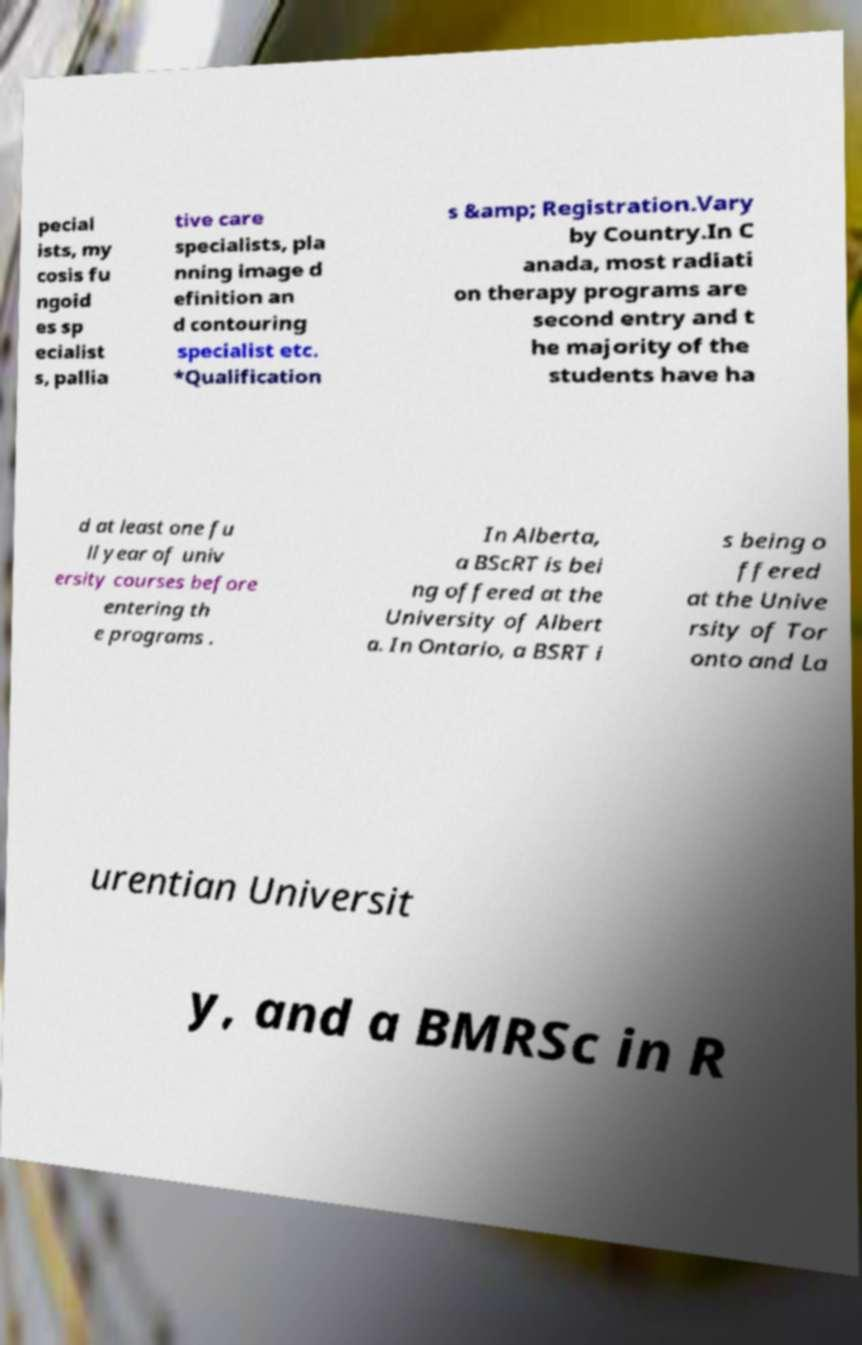What messages or text are displayed in this image? I need them in a readable, typed format. pecial ists, my cosis fu ngoid es sp ecialist s, pallia tive care specialists, pla nning image d efinition an d contouring specialist etc. *Qualification s &amp; Registration.Vary by Country.In C anada, most radiati on therapy programs are second entry and t he majority of the students have ha d at least one fu ll year of univ ersity courses before entering th e programs . In Alberta, a BScRT is bei ng offered at the University of Albert a. In Ontario, a BSRT i s being o ffered at the Unive rsity of Tor onto and La urentian Universit y, and a BMRSc in R 